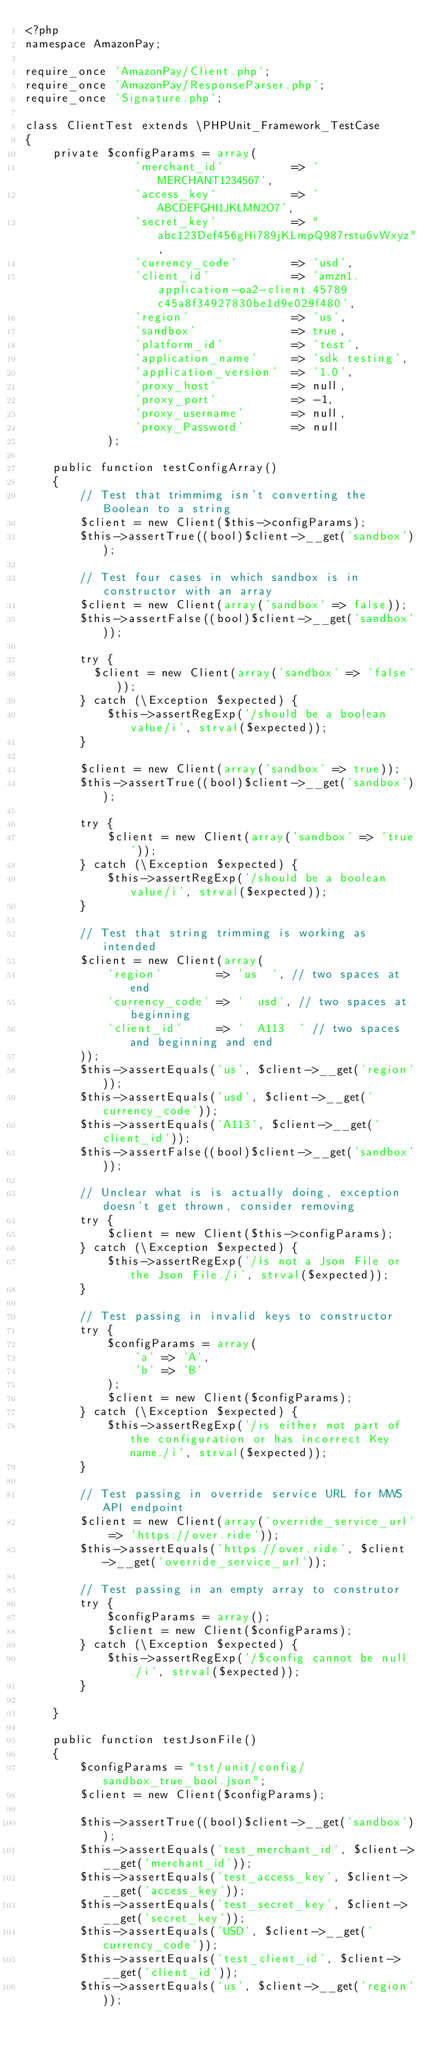Convert code to text. <code><loc_0><loc_0><loc_500><loc_500><_PHP_><?php
namespace AmazonPay;

require_once 'AmazonPay/Client.php';
require_once 'AmazonPay/ResponseParser.php';
require_once 'Signature.php';

class ClientTest extends \PHPUnit_Framework_TestCase
{
    private $configParams = array(
                'merchant_id'          => 'MERCHANT1234567',
                'access_key'           => 'ABCDEFGHI1JKLMN2O7',
                'secret_key'           => "abc123Def456gHi789jKLmpQ987rstu6vWxyz",
                'currency_code'        => 'usd',
                'client_id'            => 'amzn1.application-oa2-client.45789c45a8f34927830be1d9e029f480',
                'region'               => 'us',
                'sandbox'              => true,
                'platform_id'          => 'test',
                'application_name'     => 'sdk testing',
                'application_version'  => '1.0',
                'proxy_host'           => null,
                'proxy_port'           => -1,
                'proxy_username'       => null,
                'proxy_Password'       => null
            );

    public function testConfigArray()
    {
        // Test that trimmimg isn't converting the Boolean to a string
        $client = new Client($this->configParams);
        $this->assertTrue((bool)$client->__get('sandbox'));

        // Test four cases in which sandbox is in constructor with an array
        $client = new Client(array('sandbox' => false));
        $this->assertFalse((bool)$client->__get('sandbox'));

        try {
          $client = new Client(array('sandbox' => 'false'));
        } catch (\Exception $expected) {
            $this->assertRegExp('/should be a boolean value/i', strval($expected));
        }

        $client = new Client(array('sandbox' => true));
        $this->assertTrue((bool)$client->__get('sandbox'));

        try {
            $client = new Client(array('sandbox' => 'true'));
        } catch (\Exception $expected) {
            $this->assertRegExp('/should be a boolean value/i', strval($expected));
        }

        // Test that string trimming is working as intended
        $client = new Client(array(
            'region'        => 'us  ', // two spaces at end
            'currency_code' => '  usd', // two spaces at beginning
            'client_id'     => '  A113  ' // two spaces and beginning and end
        ));
        $this->assertEquals('us', $client->__get('region'));
        $this->assertEquals('usd', $client->__get('currency_code'));
        $this->assertEquals('A113', $client->__get('client_id'));
        $this->assertFalse((bool)$client->__get('sandbox'));

        // Unclear what is is actually doing, exception doesn't get thrown, consider removing
        try {
            $client = new Client($this->configParams);
        } catch (\Exception $expected) {
            $this->assertRegExp('/is not a Json File or the Json File./i', strval($expected));
        }

        // Test passing in invalid keys to constructor
        try {
            $configParams = array(
                'a' => 'A',
                'b' => 'B'
            );
            $client = new Client($configParams);
        } catch (\Exception $expected) {
            $this->assertRegExp('/is either not part of the configuration or has incorrect Key name./i', strval($expected));
        }

        // Test passing in override service URL for MWS API endpoint
        $client = new Client(array('override_service_url' => 'https://over.ride'));
        $this->assertEquals('https://over.ride', $client->__get('override_service_url'));

        // Test passing in an empty array to construtor
        try {
            $configParams = array();
            $client = new Client($configParams);
        } catch (\Exception $expected) {
            $this->assertRegExp('/$config cannot be null./i', strval($expected));
        }

    }

    public function testJsonFile()
    {
        $configParams = "tst/unit/config/sandbox_true_bool.json";
        $client = new Client($configParams);

        $this->assertTrue((bool)$client->__get('sandbox'));
        $this->assertEquals('test_merchant_id', $client->__get('merchant_id'));
        $this->assertEquals('test_access_key', $client->__get('access_key'));
        $this->assertEquals('test_secret_key', $client->__get('secret_key'));
        $this->assertEquals('USD', $client->__get('currency_code'));
        $this->assertEquals('test_client_id', $client->__get('client_id'));
        $this->assertEquals('us', $client->__get('region'));</code> 